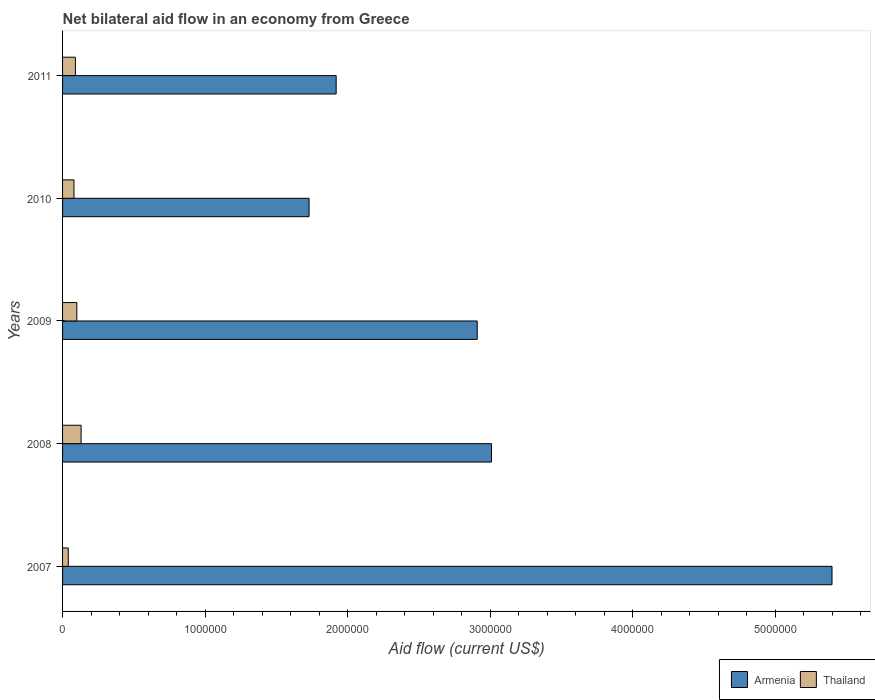How many different coloured bars are there?
Keep it short and to the point. 2. How many groups of bars are there?
Provide a succinct answer. 5. Are the number of bars per tick equal to the number of legend labels?
Offer a very short reply. Yes. How many bars are there on the 4th tick from the bottom?
Keep it short and to the point. 2. What is the label of the 3rd group of bars from the top?
Provide a succinct answer. 2009. In how many cases, is the number of bars for a given year not equal to the number of legend labels?
Offer a terse response. 0. What is the net bilateral aid flow in Armenia in 2008?
Provide a short and direct response. 3.01e+06. Across all years, what is the maximum net bilateral aid flow in Armenia?
Give a very brief answer. 5.40e+06. Across all years, what is the minimum net bilateral aid flow in Thailand?
Offer a terse response. 4.00e+04. What is the total net bilateral aid flow in Thailand in the graph?
Offer a terse response. 4.40e+05. What is the difference between the net bilateral aid flow in Thailand in 2010 and that in 2011?
Give a very brief answer. -10000. What is the difference between the net bilateral aid flow in Thailand in 2010 and the net bilateral aid flow in Armenia in 2008?
Provide a short and direct response. -2.93e+06. What is the average net bilateral aid flow in Thailand per year?
Your answer should be very brief. 8.80e+04. In the year 2007, what is the difference between the net bilateral aid flow in Armenia and net bilateral aid flow in Thailand?
Offer a very short reply. 5.36e+06. In how many years, is the net bilateral aid flow in Armenia greater than 3000000 US$?
Offer a very short reply. 2. What is the ratio of the net bilateral aid flow in Armenia in 2008 to that in 2011?
Your response must be concise. 1.57. Is the net bilateral aid flow in Armenia in 2009 less than that in 2010?
Offer a terse response. No. What is the difference between the highest and the second highest net bilateral aid flow in Armenia?
Offer a very short reply. 2.39e+06. What is the difference between the highest and the lowest net bilateral aid flow in Armenia?
Make the answer very short. 3.67e+06. In how many years, is the net bilateral aid flow in Thailand greater than the average net bilateral aid flow in Thailand taken over all years?
Offer a very short reply. 3. Is the sum of the net bilateral aid flow in Armenia in 2007 and 2011 greater than the maximum net bilateral aid flow in Thailand across all years?
Provide a succinct answer. Yes. What does the 1st bar from the top in 2011 represents?
Provide a succinct answer. Thailand. What does the 1st bar from the bottom in 2010 represents?
Offer a very short reply. Armenia. How many bars are there?
Your answer should be compact. 10. Are all the bars in the graph horizontal?
Provide a succinct answer. Yes. How many years are there in the graph?
Keep it short and to the point. 5. What is the difference between two consecutive major ticks on the X-axis?
Make the answer very short. 1.00e+06. Are the values on the major ticks of X-axis written in scientific E-notation?
Make the answer very short. No. Where does the legend appear in the graph?
Make the answer very short. Bottom right. How many legend labels are there?
Offer a terse response. 2. How are the legend labels stacked?
Your answer should be very brief. Horizontal. What is the title of the graph?
Your response must be concise. Net bilateral aid flow in an economy from Greece. Does "Spain" appear as one of the legend labels in the graph?
Give a very brief answer. No. What is the label or title of the X-axis?
Offer a very short reply. Aid flow (current US$). What is the label or title of the Y-axis?
Offer a very short reply. Years. What is the Aid flow (current US$) in Armenia in 2007?
Provide a short and direct response. 5.40e+06. What is the Aid flow (current US$) in Thailand in 2007?
Your response must be concise. 4.00e+04. What is the Aid flow (current US$) in Armenia in 2008?
Make the answer very short. 3.01e+06. What is the Aid flow (current US$) of Thailand in 2008?
Keep it short and to the point. 1.30e+05. What is the Aid flow (current US$) of Armenia in 2009?
Offer a terse response. 2.91e+06. What is the Aid flow (current US$) of Armenia in 2010?
Offer a terse response. 1.73e+06. What is the Aid flow (current US$) of Thailand in 2010?
Provide a succinct answer. 8.00e+04. What is the Aid flow (current US$) in Armenia in 2011?
Keep it short and to the point. 1.92e+06. Across all years, what is the maximum Aid flow (current US$) of Armenia?
Your answer should be very brief. 5.40e+06. Across all years, what is the minimum Aid flow (current US$) of Armenia?
Offer a very short reply. 1.73e+06. Across all years, what is the minimum Aid flow (current US$) of Thailand?
Give a very brief answer. 4.00e+04. What is the total Aid flow (current US$) of Armenia in the graph?
Give a very brief answer. 1.50e+07. What is the difference between the Aid flow (current US$) of Armenia in 2007 and that in 2008?
Ensure brevity in your answer.  2.39e+06. What is the difference between the Aid flow (current US$) in Armenia in 2007 and that in 2009?
Make the answer very short. 2.49e+06. What is the difference between the Aid flow (current US$) in Thailand in 2007 and that in 2009?
Your answer should be very brief. -6.00e+04. What is the difference between the Aid flow (current US$) in Armenia in 2007 and that in 2010?
Offer a very short reply. 3.67e+06. What is the difference between the Aid flow (current US$) of Thailand in 2007 and that in 2010?
Your answer should be very brief. -4.00e+04. What is the difference between the Aid flow (current US$) of Armenia in 2007 and that in 2011?
Offer a very short reply. 3.48e+06. What is the difference between the Aid flow (current US$) of Thailand in 2007 and that in 2011?
Your answer should be very brief. -5.00e+04. What is the difference between the Aid flow (current US$) of Armenia in 2008 and that in 2009?
Ensure brevity in your answer.  1.00e+05. What is the difference between the Aid flow (current US$) in Armenia in 2008 and that in 2010?
Ensure brevity in your answer.  1.28e+06. What is the difference between the Aid flow (current US$) in Armenia in 2008 and that in 2011?
Provide a short and direct response. 1.09e+06. What is the difference between the Aid flow (current US$) of Armenia in 2009 and that in 2010?
Offer a terse response. 1.18e+06. What is the difference between the Aid flow (current US$) of Armenia in 2009 and that in 2011?
Offer a terse response. 9.90e+05. What is the difference between the Aid flow (current US$) in Thailand in 2009 and that in 2011?
Give a very brief answer. 10000. What is the difference between the Aid flow (current US$) in Armenia in 2010 and that in 2011?
Your response must be concise. -1.90e+05. What is the difference between the Aid flow (current US$) of Armenia in 2007 and the Aid flow (current US$) of Thailand in 2008?
Your answer should be very brief. 5.27e+06. What is the difference between the Aid flow (current US$) in Armenia in 2007 and the Aid flow (current US$) in Thailand in 2009?
Your answer should be compact. 5.30e+06. What is the difference between the Aid flow (current US$) of Armenia in 2007 and the Aid flow (current US$) of Thailand in 2010?
Offer a terse response. 5.32e+06. What is the difference between the Aid flow (current US$) in Armenia in 2007 and the Aid flow (current US$) in Thailand in 2011?
Your answer should be compact. 5.31e+06. What is the difference between the Aid flow (current US$) in Armenia in 2008 and the Aid flow (current US$) in Thailand in 2009?
Offer a terse response. 2.91e+06. What is the difference between the Aid flow (current US$) of Armenia in 2008 and the Aid flow (current US$) of Thailand in 2010?
Your response must be concise. 2.93e+06. What is the difference between the Aid flow (current US$) of Armenia in 2008 and the Aid flow (current US$) of Thailand in 2011?
Provide a short and direct response. 2.92e+06. What is the difference between the Aid flow (current US$) in Armenia in 2009 and the Aid flow (current US$) in Thailand in 2010?
Keep it short and to the point. 2.83e+06. What is the difference between the Aid flow (current US$) of Armenia in 2009 and the Aid flow (current US$) of Thailand in 2011?
Provide a succinct answer. 2.82e+06. What is the difference between the Aid flow (current US$) of Armenia in 2010 and the Aid flow (current US$) of Thailand in 2011?
Your answer should be compact. 1.64e+06. What is the average Aid flow (current US$) in Armenia per year?
Your answer should be compact. 2.99e+06. What is the average Aid flow (current US$) in Thailand per year?
Your answer should be very brief. 8.80e+04. In the year 2007, what is the difference between the Aid flow (current US$) in Armenia and Aid flow (current US$) in Thailand?
Provide a short and direct response. 5.36e+06. In the year 2008, what is the difference between the Aid flow (current US$) of Armenia and Aid flow (current US$) of Thailand?
Offer a very short reply. 2.88e+06. In the year 2009, what is the difference between the Aid flow (current US$) of Armenia and Aid flow (current US$) of Thailand?
Give a very brief answer. 2.81e+06. In the year 2010, what is the difference between the Aid flow (current US$) in Armenia and Aid flow (current US$) in Thailand?
Give a very brief answer. 1.65e+06. In the year 2011, what is the difference between the Aid flow (current US$) of Armenia and Aid flow (current US$) of Thailand?
Provide a succinct answer. 1.83e+06. What is the ratio of the Aid flow (current US$) of Armenia in 2007 to that in 2008?
Offer a very short reply. 1.79. What is the ratio of the Aid flow (current US$) in Thailand in 2007 to that in 2008?
Offer a very short reply. 0.31. What is the ratio of the Aid flow (current US$) in Armenia in 2007 to that in 2009?
Make the answer very short. 1.86. What is the ratio of the Aid flow (current US$) of Armenia in 2007 to that in 2010?
Provide a succinct answer. 3.12. What is the ratio of the Aid flow (current US$) in Thailand in 2007 to that in 2010?
Make the answer very short. 0.5. What is the ratio of the Aid flow (current US$) in Armenia in 2007 to that in 2011?
Provide a short and direct response. 2.81. What is the ratio of the Aid flow (current US$) in Thailand in 2007 to that in 2011?
Your answer should be compact. 0.44. What is the ratio of the Aid flow (current US$) in Armenia in 2008 to that in 2009?
Make the answer very short. 1.03. What is the ratio of the Aid flow (current US$) in Armenia in 2008 to that in 2010?
Your answer should be very brief. 1.74. What is the ratio of the Aid flow (current US$) in Thailand in 2008 to that in 2010?
Your response must be concise. 1.62. What is the ratio of the Aid flow (current US$) of Armenia in 2008 to that in 2011?
Make the answer very short. 1.57. What is the ratio of the Aid flow (current US$) in Thailand in 2008 to that in 2011?
Your answer should be very brief. 1.44. What is the ratio of the Aid flow (current US$) of Armenia in 2009 to that in 2010?
Make the answer very short. 1.68. What is the ratio of the Aid flow (current US$) of Armenia in 2009 to that in 2011?
Give a very brief answer. 1.52. What is the ratio of the Aid flow (current US$) of Thailand in 2009 to that in 2011?
Your response must be concise. 1.11. What is the ratio of the Aid flow (current US$) in Armenia in 2010 to that in 2011?
Provide a succinct answer. 0.9. What is the difference between the highest and the second highest Aid flow (current US$) of Armenia?
Provide a short and direct response. 2.39e+06. What is the difference between the highest and the lowest Aid flow (current US$) of Armenia?
Your answer should be compact. 3.67e+06. 